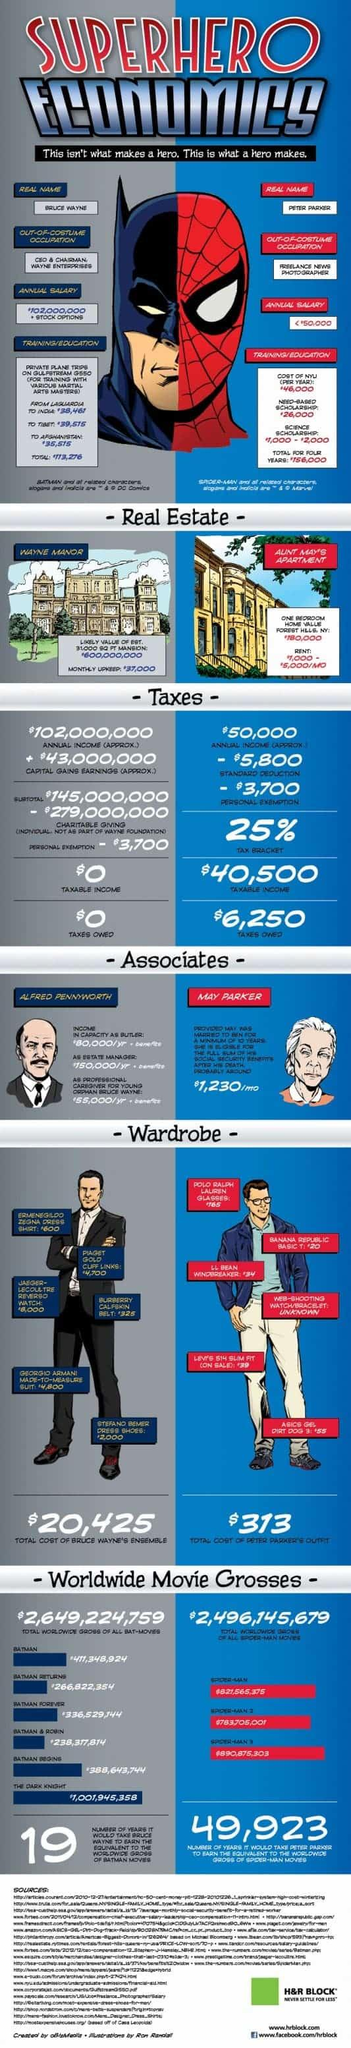Specify some key components in this picture. Alfred Pennyworth's salary as Bruce Wayne's butler is equivalent to 28% of his total earnings. The yearly net worth difference between Alfred Pennyworth and May Parker is $270,240. The annual salary of Alfred Pennyworth is $285,000. May Parker's annual income is $14,760. 